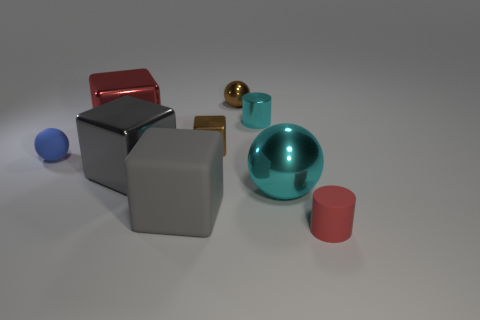Subtract all big blocks. How many blocks are left? 1 Subtract all red cylinders. How many cylinders are left? 1 Subtract 2 cubes. How many cubes are left? 2 Subtract all balls. How many objects are left? 6 Subtract all yellow cylinders. How many cyan spheres are left? 1 Subtract all cyan cylinders. Subtract all small rubber objects. How many objects are left? 6 Add 7 matte balls. How many matte balls are left? 8 Add 3 big cubes. How many big cubes exist? 6 Subtract 1 red blocks. How many objects are left? 8 Subtract all red cubes. Subtract all yellow spheres. How many cubes are left? 3 